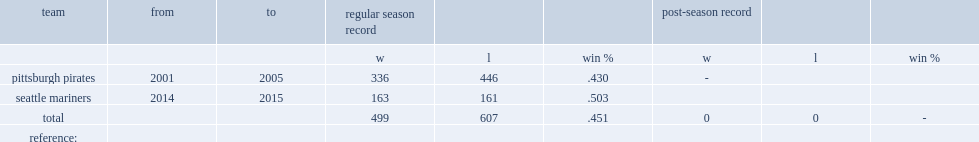What was the w-l record of the pirates? 336.0 446.0. Would you be able to parse every entry in this table? {'header': ['team', 'from', 'to', 'regular season record', '', '', 'post-season record', '', ''], 'rows': [['', '', '', 'w', 'l', 'win %', 'w', 'l', 'win %'], ['pittsburgh pirates', '2001', '2005', '336', '446', '.430', '-', '', ''], ['seattle mariners', '2014', '2015', '163', '161', '.503', '', '', ''], ['total', '', '', '499', '607', '.451', '0', '0', '-'], ['reference:', '', '', '', '', '', '', '', '']]} 